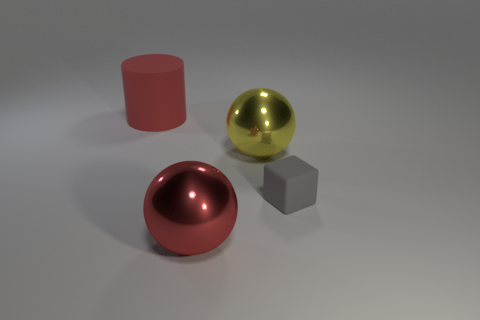How many tiny matte cubes are there?
Make the answer very short. 1. There is a object that is behind the matte cube and in front of the big matte cylinder; what shape is it?
Keep it short and to the point. Sphere. The rubber object that is to the right of the big thing in front of the matte thing that is in front of the large cylinder is what shape?
Keep it short and to the point. Cube. There is a thing that is in front of the yellow metal sphere and on the left side of the yellow metallic thing; what is its material?
Provide a succinct answer. Metal. What number of red rubber things are the same size as the gray block?
Make the answer very short. 0. How many matte things are either big red balls or large yellow balls?
Ensure brevity in your answer.  0. What is the material of the gray block?
Offer a terse response. Rubber. There is a red cylinder; how many red matte objects are to the right of it?
Offer a very short reply. 0. Do the red ball that is in front of the cylinder and the tiny gray cube have the same material?
Provide a succinct answer. No. How many big yellow things are the same shape as the large red metal object?
Your answer should be compact. 1. 